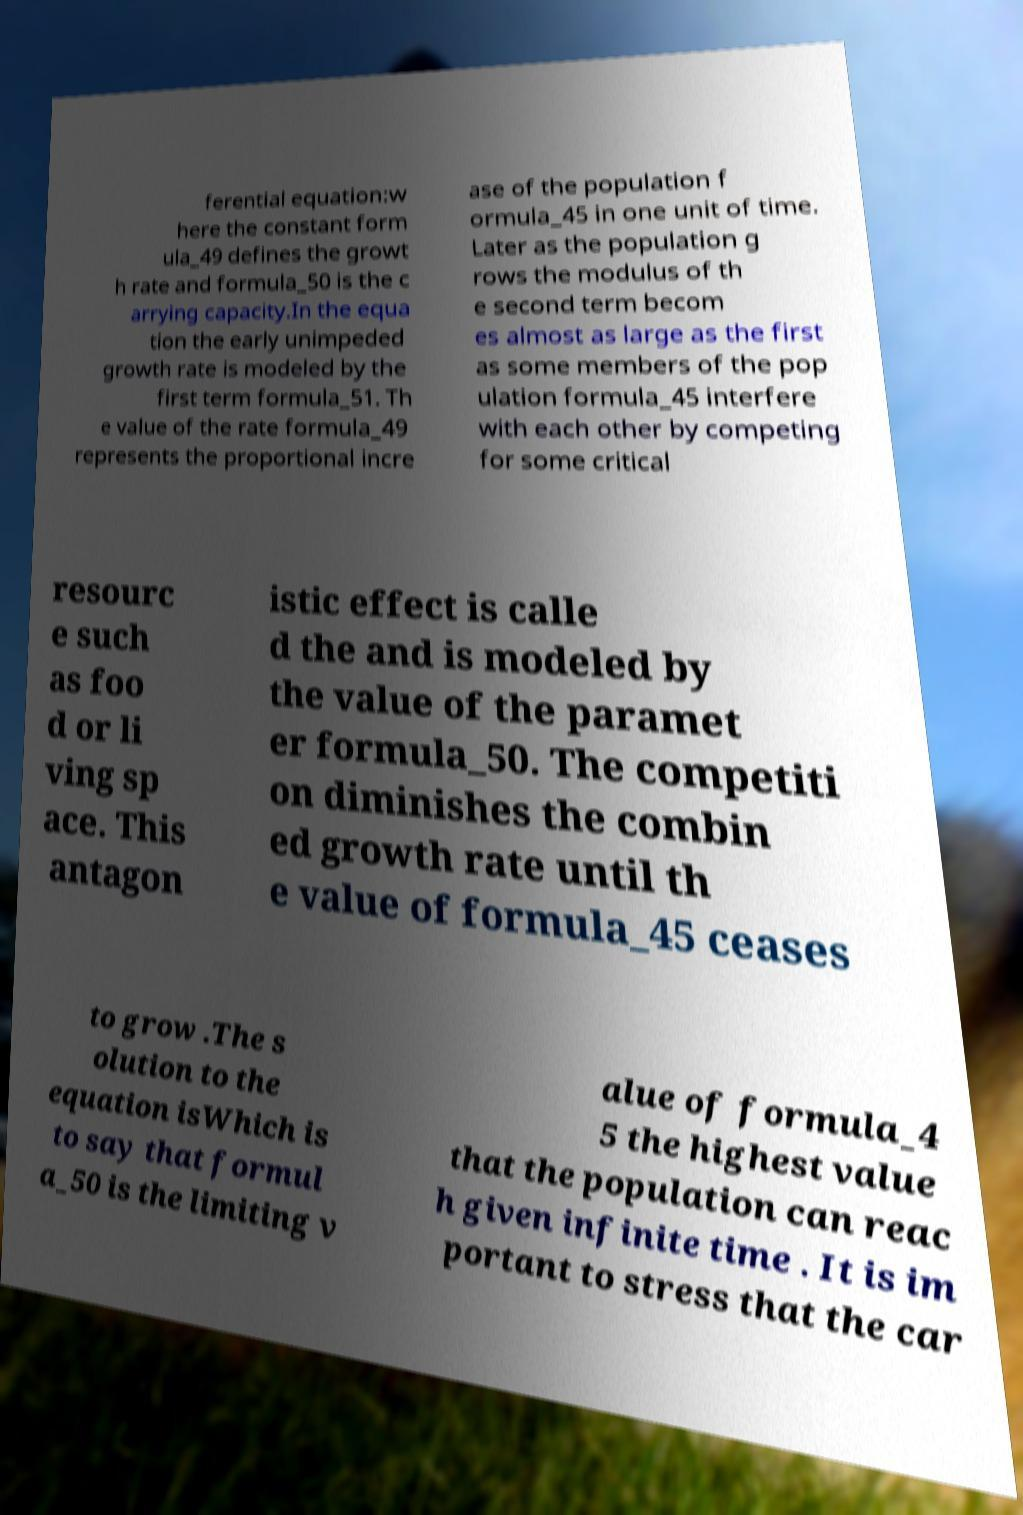I need the written content from this picture converted into text. Can you do that? ferential equation:w here the constant form ula_49 defines the growt h rate and formula_50 is the c arrying capacity.In the equa tion the early unimpeded growth rate is modeled by the first term formula_51. Th e value of the rate formula_49 represents the proportional incre ase of the population f ormula_45 in one unit of time. Later as the population g rows the modulus of th e second term becom es almost as large as the first as some members of the pop ulation formula_45 interfere with each other by competing for some critical resourc e such as foo d or li ving sp ace. This antagon istic effect is calle d the and is modeled by the value of the paramet er formula_50. The competiti on diminishes the combin ed growth rate until th e value of formula_45 ceases to grow .The s olution to the equation isWhich is to say that formul a_50 is the limiting v alue of formula_4 5 the highest value that the population can reac h given infinite time . It is im portant to stress that the car 